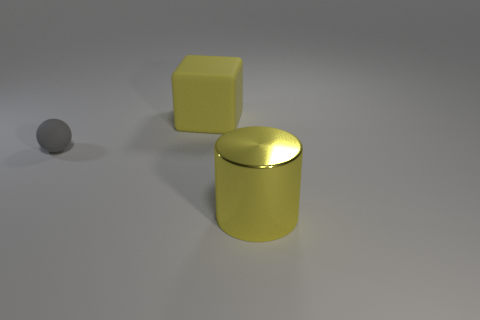Is there any other thing that is the same material as the large yellow cylinder?
Your answer should be compact. No. Is the size of the yellow matte block the same as the metallic thing?
Make the answer very short. Yes. How many other tiny balls are the same material as the sphere?
Your response must be concise. 0. There is a rubber thing that is the same color as the big metal cylinder; what is its shape?
Your answer should be compact. Cube. What is the color of the small ball?
Make the answer very short. Gray. What number of objects are either matte balls to the left of the big yellow block or big yellow blocks?
Provide a short and direct response. 2. The yellow thing that is the same size as the cylinder is what shape?
Your answer should be compact. Cube. The large yellow object in front of the matte object that is in front of the yellow object that is behind the small ball is what shape?
Provide a succinct answer. Cylinder. How many big things are yellow matte objects or metallic cylinders?
Keep it short and to the point. 2. Are there any green rubber blocks that have the same size as the yellow matte object?
Provide a short and direct response. No. 